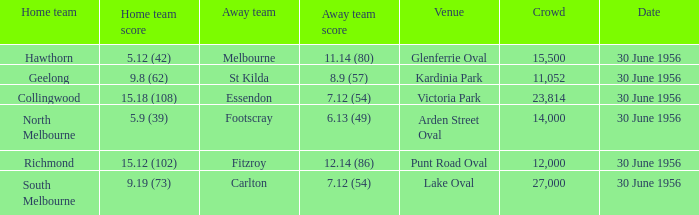What is the home squad score when the away team is st kilda? 9.8 (62). 